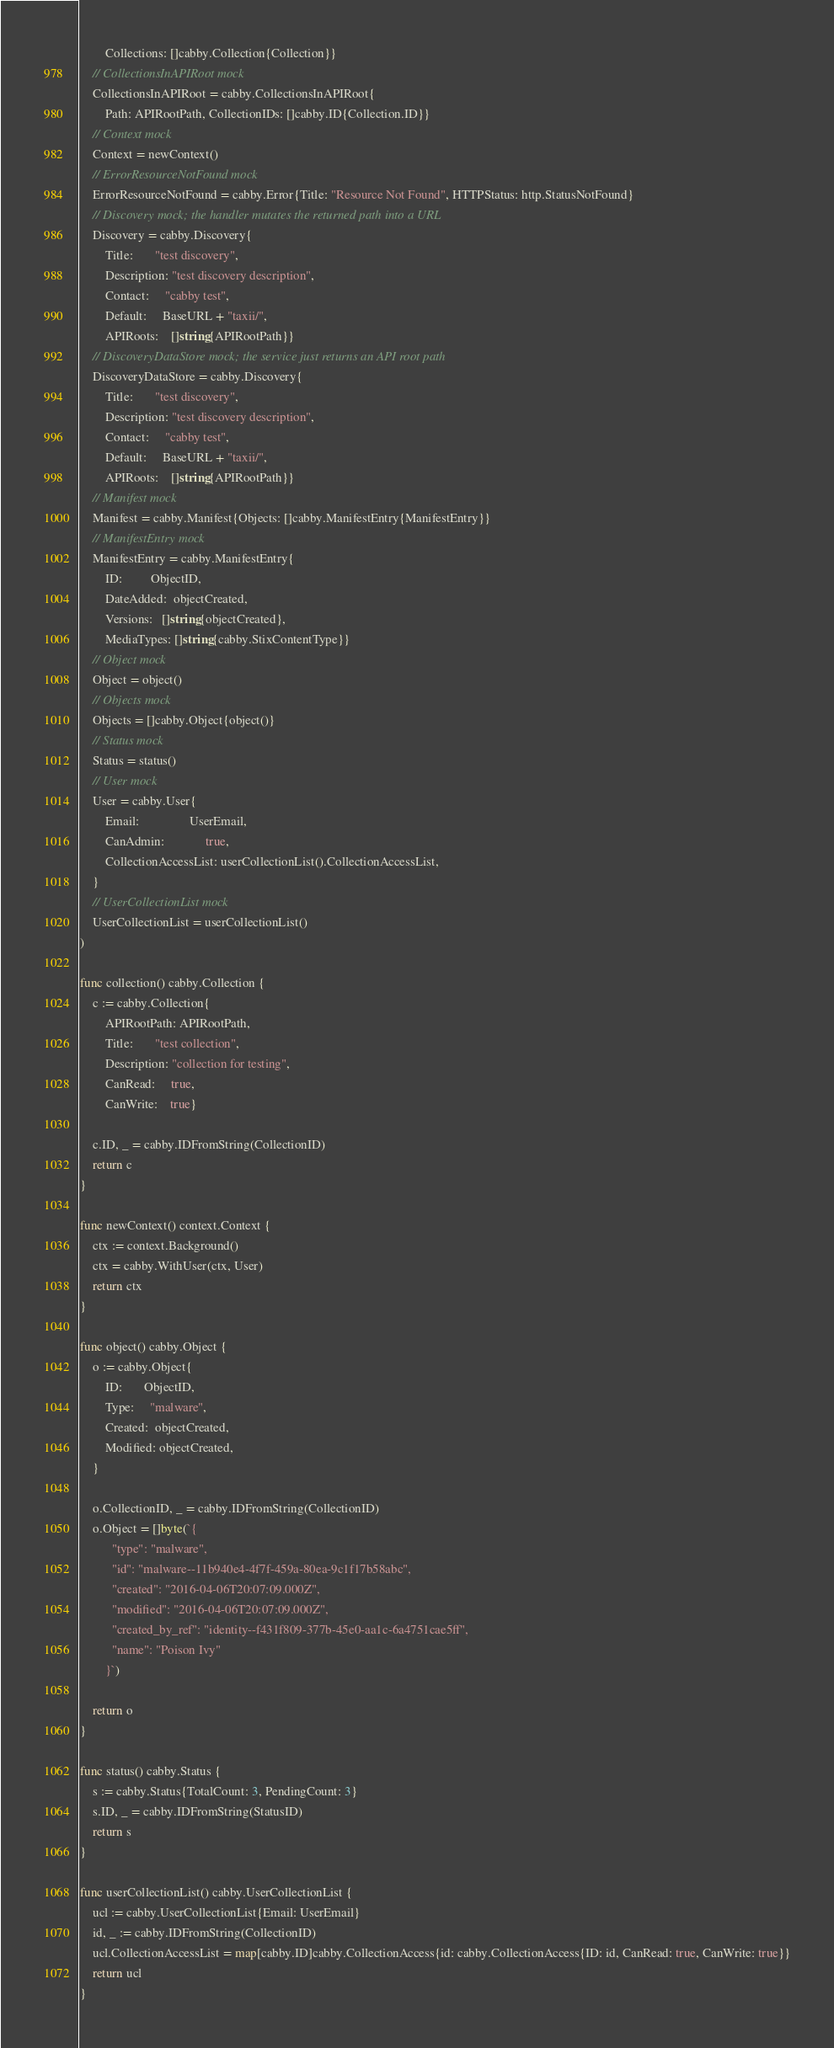<code> <loc_0><loc_0><loc_500><loc_500><_Go_>		Collections: []cabby.Collection{Collection}}
	// CollectionsInAPIRoot mock
	CollectionsInAPIRoot = cabby.CollectionsInAPIRoot{
		Path: APIRootPath, CollectionIDs: []cabby.ID{Collection.ID}}
	// Context mock
	Context = newContext()
	// ErrorResourceNotFound mock
	ErrorResourceNotFound = cabby.Error{Title: "Resource Not Found", HTTPStatus: http.StatusNotFound}
	// Discovery mock; the handler mutates the returned path into a URL
	Discovery = cabby.Discovery{
		Title:       "test discovery",
		Description: "test discovery description",
		Contact:     "cabby test",
		Default:     BaseURL + "taxii/",
		APIRoots:    []string{APIRootPath}}
	// DiscoveryDataStore mock; the service just returns an API root path
	DiscoveryDataStore = cabby.Discovery{
		Title:       "test discovery",
		Description: "test discovery description",
		Contact:     "cabby test",
		Default:     BaseURL + "taxii/",
		APIRoots:    []string{APIRootPath}}
	// Manifest mock
	Manifest = cabby.Manifest{Objects: []cabby.ManifestEntry{ManifestEntry}}
	// ManifestEntry mock
	ManifestEntry = cabby.ManifestEntry{
		ID:         ObjectID,
		DateAdded:  objectCreated,
		Versions:   []string{objectCreated},
		MediaTypes: []string{cabby.StixContentType}}
	// Object mock
	Object = object()
	// Objects mock
	Objects = []cabby.Object{object()}
	// Status mock
	Status = status()
	// User mock
	User = cabby.User{
		Email:                UserEmail,
		CanAdmin:             true,
		CollectionAccessList: userCollectionList().CollectionAccessList,
	}
	// UserCollectionList mock
	UserCollectionList = userCollectionList()
)

func collection() cabby.Collection {
	c := cabby.Collection{
		APIRootPath: APIRootPath,
		Title:       "test collection",
		Description: "collection for testing",
		CanRead:     true,
		CanWrite:    true}

	c.ID, _ = cabby.IDFromString(CollectionID)
	return c
}

func newContext() context.Context {
	ctx := context.Background()
	ctx = cabby.WithUser(ctx, User)
	return ctx
}

func object() cabby.Object {
	o := cabby.Object{
		ID:       ObjectID,
		Type:     "malware",
		Created:  objectCreated,
		Modified: objectCreated,
	}

	o.CollectionID, _ = cabby.IDFromString(CollectionID)
	o.Object = []byte(`{
	      "type": "malware",
	      "id": "malware--11b940e4-4f7f-459a-80ea-9c1f17b58abc",
	      "created": "2016-04-06T20:07:09.000Z",
	      "modified": "2016-04-06T20:07:09.000Z",
	      "created_by_ref": "identity--f431f809-377b-45e0-aa1c-6a4751cae5ff",
	      "name": "Poison Ivy"
	    }`)

	return o
}

func status() cabby.Status {
	s := cabby.Status{TotalCount: 3, PendingCount: 3}
	s.ID, _ = cabby.IDFromString(StatusID)
	return s
}

func userCollectionList() cabby.UserCollectionList {
	ucl := cabby.UserCollectionList{Email: UserEmail}
	id, _ := cabby.IDFromString(CollectionID)
	ucl.CollectionAccessList = map[cabby.ID]cabby.CollectionAccess{id: cabby.CollectionAccess{ID: id, CanRead: true, CanWrite: true}}
	return ucl
}
</code> 